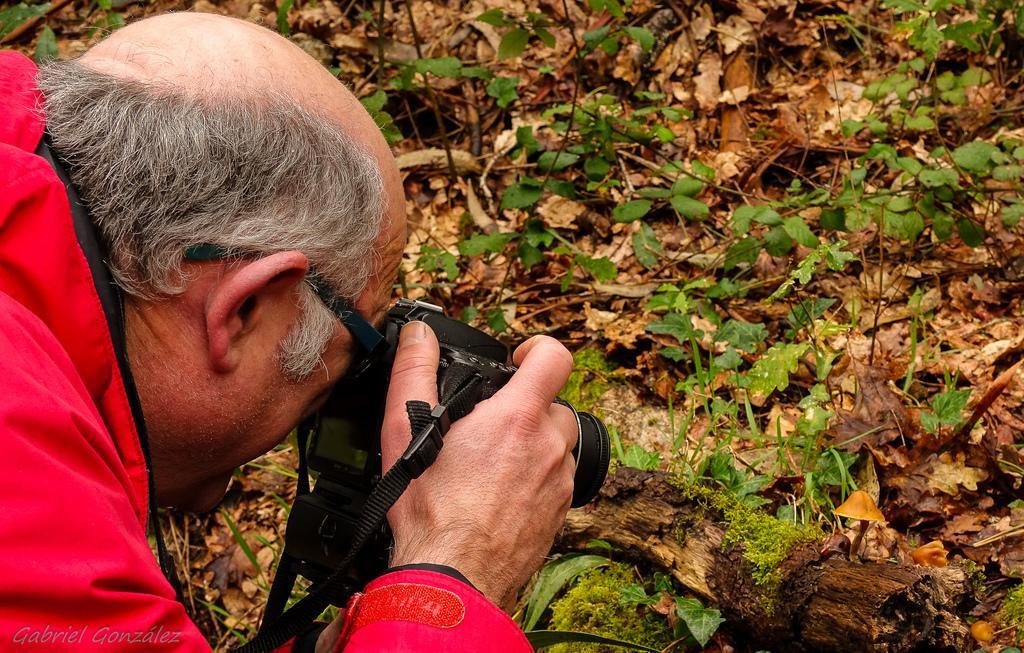Please provide a concise description of this image. In the image we can see a man wearing clothes, spectacles and the man is holding a camera in his hand. These are the dry leaves, wooden log and grass. 